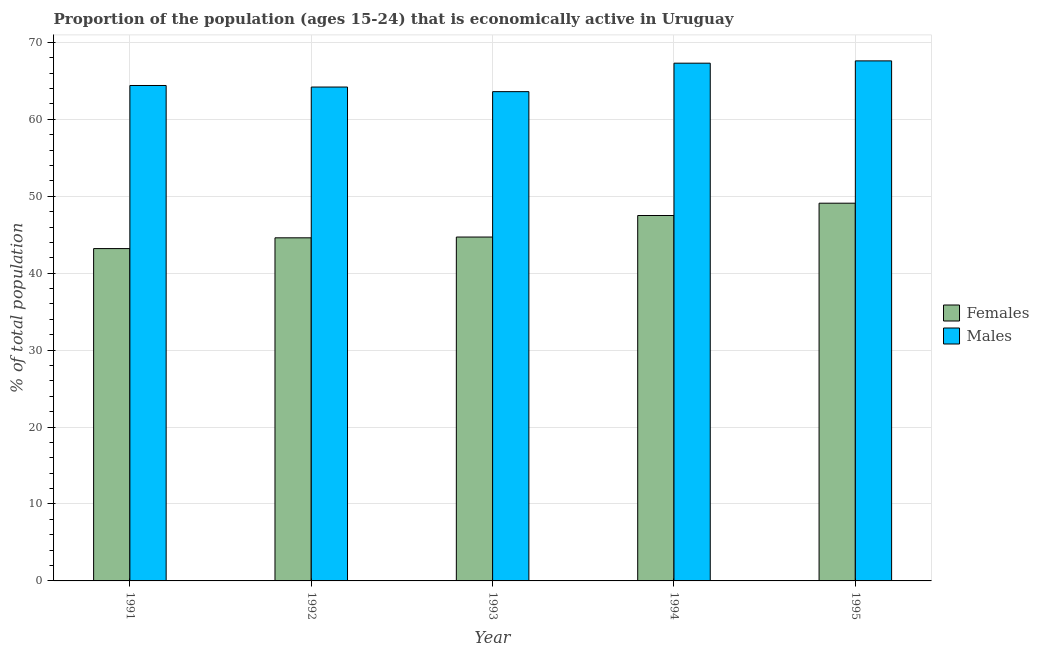How many groups of bars are there?
Your response must be concise. 5. Are the number of bars per tick equal to the number of legend labels?
Keep it short and to the point. Yes. How many bars are there on the 4th tick from the left?
Ensure brevity in your answer.  2. What is the percentage of economically active male population in 1992?
Your response must be concise. 64.2. Across all years, what is the maximum percentage of economically active female population?
Make the answer very short. 49.1. Across all years, what is the minimum percentage of economically active male population?
Make the answer very short. 63.6. In which year was the percentage of economically active female population minimum?
Your answer should be very brief. 1991. What is the total percentage of economically active female population in the graph?
Your answer should be compact. 229.1. What is the difference between the percentage of economically active male population in 1992 and that in 1995?
Provide a short and direct response. -3.4. What is the difference between the percentage of economically active male population in 1991 and the percentage of economically active female population in 1992?
Offer a very short reply. 0.2. What is the average percentage of economically active female population per year?
Provide a succinct answer. 45.82. In the year 1993, what is the difference between the percentage of economically active female population and percentage of economically active male population?
Provide a short and direct response. 0. In how many years, is the percentage of economically active female population greater than 12 %?
Give a very brief answer. 5. What is the ratio of the percentage of economically active female population in 1991 to that in 1993?
Keep it short and to the point. 0.97. Is the percentage of economically active female population in 1992 less than that in 1993?
Your answer should be very brief. Yes. Is the difference between the percentage of economically active female population in 1992 and 1994 greater than the difference between the percentage of economically active male population in 1992 and 1994?
Your response must be concise. No. What is the difference between the highest and the second highest percentage of economically active female population?
Your answer should be very brief. 1.6. What is the difference between the highest and the lowest percentage of economically active female population?
Keep it short and to the point. 5.9. In how many years, is the percentage of economically active female population greater than the average percentage of economically active female population taken over all years?
Your answer should be very brief. 2. What does the 1st bar from the left in 1992 represents?
Make the answer very short. Females. What does the 2nd bar from the right in 1993 represents?
Provide a short and direct response. Females. How many bars are there?
Offer a very short reply. 10. Are all the bars in the graph horizontal?
Provide a succinct answer. No. What is the difference between two consecutive major ticks on the Y-axis?
Your answer should be very brief. 10. Are the values on the major ticks of Y-axis written in scientific E-notation?
Offer a terse response. No. Does the graph contain any zero values?
Your response must be concise. No. Where does the legend appear in the graph?
Ensure brevity in your answer.  Center right. What is the title of the graph?
Offer a very short reply. Proportion of the population (ages 15-24) that is economically active in Uruguay. Does "Manufacturing industries and construction" appear as one of the legend labels in the graph?
Make the answer very short. No. What is the label or title of the X-axis?
Offer a very short reply. Year. What is the label or title of the Y-axis?
Make the answer very short. % of total population. What is the % of total population in Females in 1991?
Your response must be concise. 43.2. What is the % of total population in Males in 1991?
Ensure brevity in your answer.  64.4. What is the % of total population in Females in 1992?
Your answer should be very brief. 44.6. What is the % of total population of Males in 1992?
Your answer should be very brief. 64.2. What is the % of total population in Females in 1993?
Your response must be concise. 44.7. What is the % of total population in Males in 1993?
Offer a very short reply. 63.6. What is the % of total population in Females in 1994?
Ensure brevity in your answer.  47.5. What is the % of total population in Males in 1994?
Your response must be concise. 67.3. What is the % of total population in Females in 1995?
Make the answer very short. 49.1. What is the % of total population of Males in 1995?
Provide a short and direct response. 67.6. Across all years, what is the maximum % of total population of Females?
Ensure brevity in your answer.  49.1. Across all years, what is the maximum % of total population of Males?
Make the answer very short. 67.6. Across all years, what is the minimum % of total population of Females?
Your response must be concise. 43.2. Across all years, what is the minimum % of total population of Males?
Keep it short and to the point. 63.6. What is the total % of total population of Females in the graph?
Give a very brief answer. 229.1. What is the total % of total population in Males in the graph?
Offer a very short reply. 327.1. What is the difference between the % of total population in Females in 1991 and that in 1992?
Make the answer very short. -1.4. What is the difference between the % of total population of Females in 1991 and that in 1993?
Your answer should be very brief. -1.5. What is the difference between the % of total population in Females in 1991 and that in 1994?
Ensure brevity in your answer.  -4.3. What is the difference between the % of total population in Males in 1991 and that in 1995?
Provide a succinct answer. -3.2. What is the difference between the % of total population of Females in 1992 and that in 1993?
Provide a short and direct response. -0.1. What is the difference between the % of total population in Females in 1992 and that in 1994?
Your answer should be very brief. -2.9. What is the difference between the % of total population of Females in 1992 and that in 1995?
Give a very brief answer. -4.5. What is the difference between the % of total population of Males in 1992 and that in 1995?
Provide a short and direct response. -3.4. What is the difference between the % of total population in Females in 1993 and that in 1994?
Provide a short and direct response. -2.8. What is the difference between the % of total population in Males in 1993 and that in 1994?
Make the answer very short. -3.7. What is the difference between the % of total population in Females in 1993 and that in 1995?
Ensure brevity in your answer.  -4.4. What is the difference between the % of total population in Females in 1991 and the % of total population in Males in 1992?
Keep it short and to the point. -21. What is the difference between the % of total population in Females in 1991 and the % of total population in Males in 1993?
Provide a succinct answer. -20.4. What is the difference between the % of total population of Females in 1991 and the % of total population of Males in 1994?
Offer a terse response. -24.1. What is the difference between the % of total population of Females in 1991 and the % of total population of Males in 1995?
Your response must be concise. -24.4. What is the difference between the % of total population in Females in 1992 and the % of total population in Males in 1993?
Offer a very short reply. -19. What is the difference between the % of total population of Females in 1992 and the % of total population of Males in 1994?
Give a very brief answer. -22.7. What is the difference between the % of total population in Females in 1992 and the % of total population in Males in 1995?
Make the answer very short. -23. What is the difference between the % of total population in Females in 1993 and the % of total population in Males in 1994?
Provide a succinct answer. -22.6. What is the difference between the % of total population of Females in 1993 and the % of total population of Males in 1995?
Your answer should be very brief. -22.9. What is the difference between the % of total population in Females in 1994 and the % of total population in Males in 1995?
Your answer should be very brief. -20.1. What is the average % of total population in Females per year?
Offer a very short reply. 45.82. What is the average % of total population of Males per year?
Your answer should be very brief. 65.42. In the year 1991, what is the difference between the % of total population in Females and % of total population in Males?
Make the answer very short. -21.2. In the year 1992, what is the difference between the % of total population of Females and % of total population of Males?
Provide a short and direct response. -19.6. In the year 1993, what is the difference between the % of total population in Females and % of total population in Males?
Provide a short and direct response. -18.9. In the year 1994, what is the difference between the % of total population of Females and % of total population of Males?
Offer a terse response. -19.8. In the year 1995, what is the difference between the % of total population in Females and % of total population in Males?
Offer a very short reply. -18.5. What is the ratio of the % of total population in Females in 1991 to that in 1992?
Your answer should be very brief. 0.97. What is the ratio of the % of total population in Females in 1991 to that in 1993?
Provide a succinct answer. 0.97. What is the ratio of the % of total population in Males in 1991 to that in 1993?
Offer a terse response. 1.01. What is the ratio of the % of total population in Females in 1991 to that in 1994?
Your answer should be very brief. 0.91. What is the ratio of the % of total population in Males in 1991 to that in 1994?
Your response must be concise. 0.96. What is the ratio of the % of total population of Females in 1991 to that in 1995?
Offer a terse response. 0.88. What is the ratio of the % of total population of Males in 1991 to that in 1995?
Provide a succinct answer. 0.95. What is the ratio of the % of total population in Males in 1992 to that in 1993?
Provide a succinct answer. 1.01. What is the ratio of the % of total population of Females in 1992 to that in 1994?
Ensure brevity in your answer.  0.94. What is the ratio of the % of total population of Males in 1992 to that in 1994?
Your response must be concise. 0.95. What is the ratio of the % of total population of Females in 1992 to that in 1995?
Keep it short and to the point. 0.91. What is the ratio of the % of total population of Males in 1992 to that in 1995?
Give a very brief answer. 0.95. What is the ratio of the % of total population of Females in 1993 to that in 1994?
Provide a short and direct response. 0.94. What is the ratio of the % of total population in Males in 1993 to that in 1994?
Offer a very short reply. 0.94. What is the ratio of the % of total population of Females in 1993 to that in 1995?
Provide a succinct answer. 0.91. What is the ratio of the % of total population of Males in 1993 to that in 1995?
Provide a succinct answer. 0.94. What is the ratio of the % of total population in Females in 1994 to that in 1995?
Ensure brevity in your answer.  0.97. What is the ratio of the % of total population of Males in 1994 to that in 1995?
Make the answer very short. 1. What is the difference between the highest and the second highest % of total population of Males?
Your answer should be compact. 0.3. What is the difference between the highest and the lowest % of total population in Females?
Offer a terse response. 5.9. What is the difference between the highest and the lowest % of total population of Males?
Provide a succinct answer. 4. 